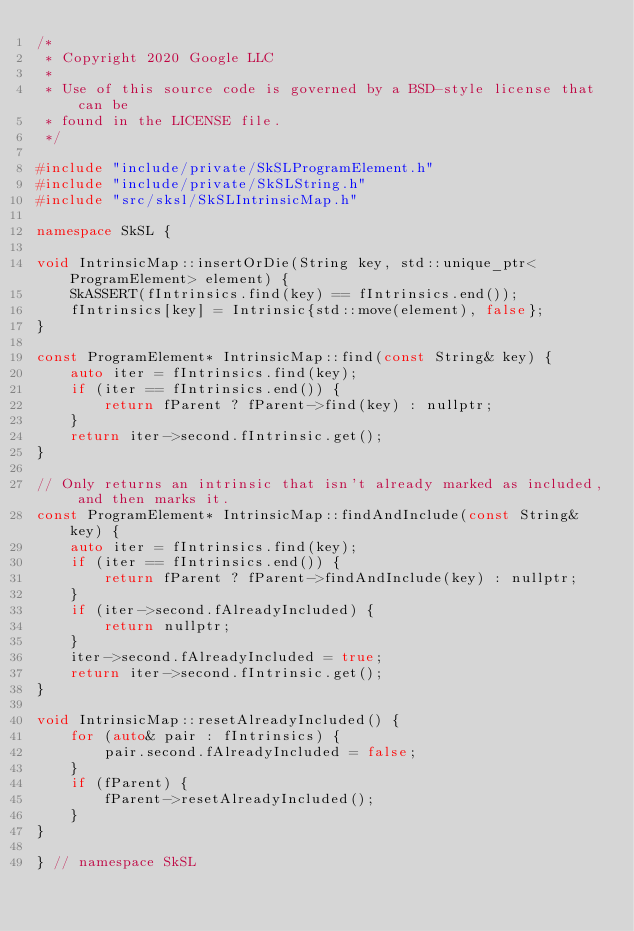Convert code to text. <code><loc_0><loc_0><loc_500><loc_500><_C++_>/*
 * Copyright 2020 Google LLC
 *
 * Use of this source code is governed by a BSD-style license that can be
 * found in the LICENSE file.
 */

#include "include/private/SkSLProgramElement.h"
#include "include/private/SkSLString.h"
#include "src/sksl/SkSLIntrinsicMap.h"

namespace SkSL {

void IntrinsicMap::insertOrDie(String key, std::unique_ptr<ProgramElement> element) {
    SkASSERT(fIntrinsics.find(key) == fIntrinsics.end());
    fIntrinsics[key] = Intrinsic{std::move(element), false};
}

const ProgramElement* IntrinsicMap::find(const String& key) {
    auto iter = fIntrinsics.find(key);
    if (iter == fIntrinsics.end()) {
        return fParent ? fParent->find(key) : nullptr;
    }
    return iter->second.fIntrinsic.get();
}

// Only returns an intrinsic that isn't already marked as included, and then marks it.
const ProgramElement* IntrinsicMap::findAndInclude(const String& key) {
    auto iter = fIntrinsics.find(key);
    if (iter == fIntrinsics.end()) {
        return fParent ? fParent->findAndInclude(key) : nullptr;
    }
    if (iter->second.fAlreadyIncluded) {
        return nullptr;
    }
    iter->second.fAlreadyIncluded = true;
    return iter->second.fIntrinsic.get();
}

void IntrinsicMap::resetAlreadyIncluded() {
    for (auto& pair : fIntrinsics) {
        pair.second.fAlreadyIncluded = false;
    }
    if (fParent) {
        fParent->resetAlreadyIncluded();
    }
}

} // namespace SkSL
</code> 